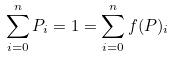Convert formula to latex. <formula><loc_0><loc_0><loc_500><loc_500>\sum _ { i = 0 } ^ { n } { P _ { i } } = 1 = \sum _ { i = 0 } ^ { n } { f ( P ) _ { i } }</formula> 